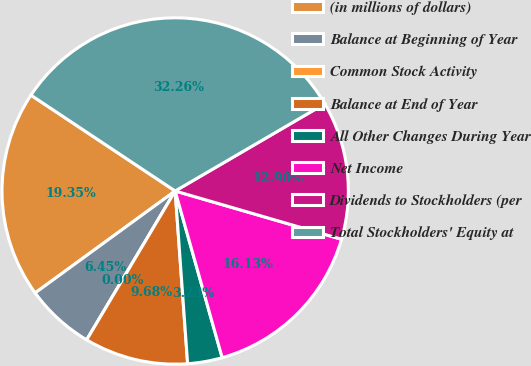<chart> <loc_0><loc_0><loc_500><loc_500><pie_chart><fcel>(in millions of dollars)<fcel>Balance at Beginning of Year<fcel>Common Stock Activity<fcel>Balance at End of Year<fcel>All Other Changes During Year<fcel>Net Income<fcel>Dividends to Stockholders (per<fcel>Total Stockholders' Equity at<nl><fcel>19.35%<fcel>6.45%<fcel>0.0%<fcel>9.68%<fcel>3.23%<fcel>16.13%<fcel>12.9%<fcel>32.26%<nl></chart> 